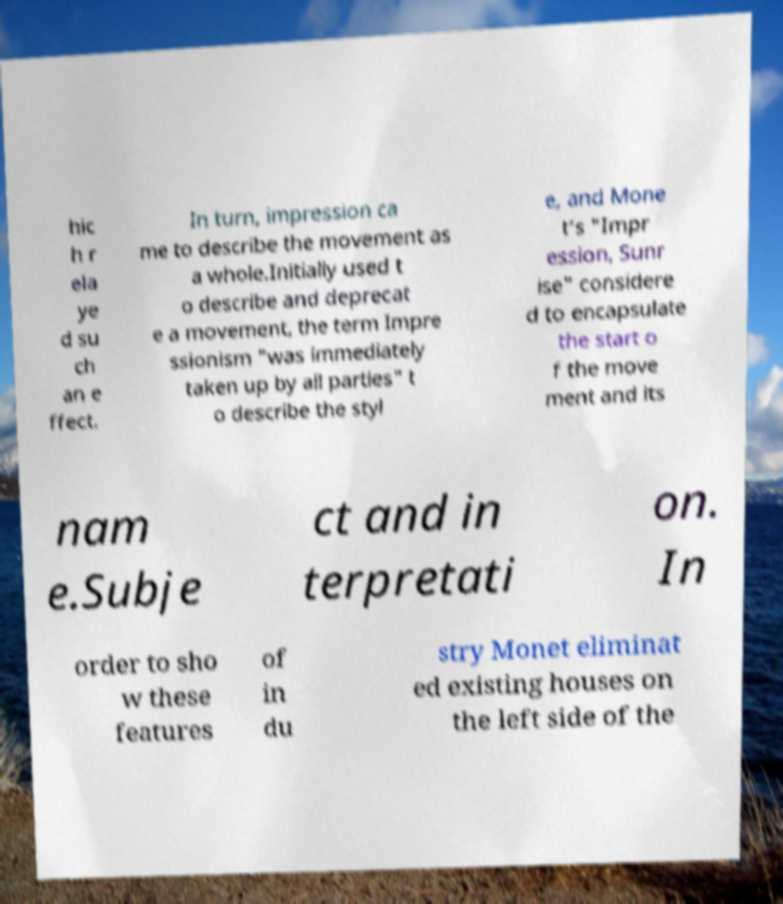For documentation purposes, I need the text within this image transcribed. Could you provide that? hic h r ela ye d su ch an e ffect. In turn, impression ca me to describe the movement as a whole.Initially used t o describe and deprecat e a movement, the term Impre ssionism "was immediately taken up by all parties" t o describe the styl e, and Mone t’s "Impr ession, Sunr ise" considere d to encapsulate the start o f the move ment and its nam e.Subje ct and in terpretati on. In order to sho w these features of in du stry Monet eliminat ed existing houses on the left side of the 